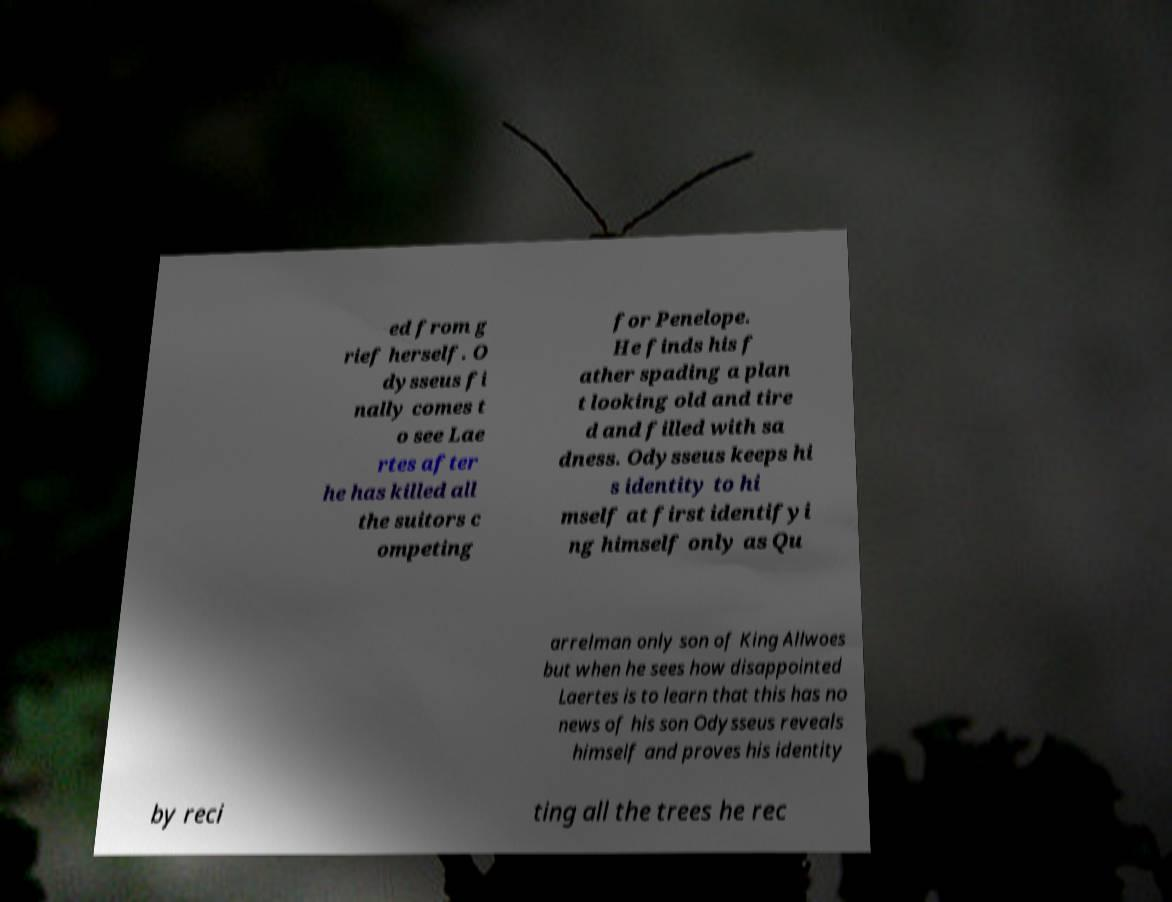Can you accurately transcribe the text from the provided image for me? ed from g rief herself. O dysseus fi nally comes t o see Lae rtes after he has killed all the suitors c ompeting for Penelope. He finds his f ather spading a plan t looking old and tire d and filled with sa dness. Odysseus keeps hi s identity to hi mself at first identifyi ng himself only as Qu arrelman only son of King Allwoes but when he sees how disappointed Laertes is to learn that this has no news of his son Odysseus reveals himself and proves his identity by reci ting all the trees he rec 